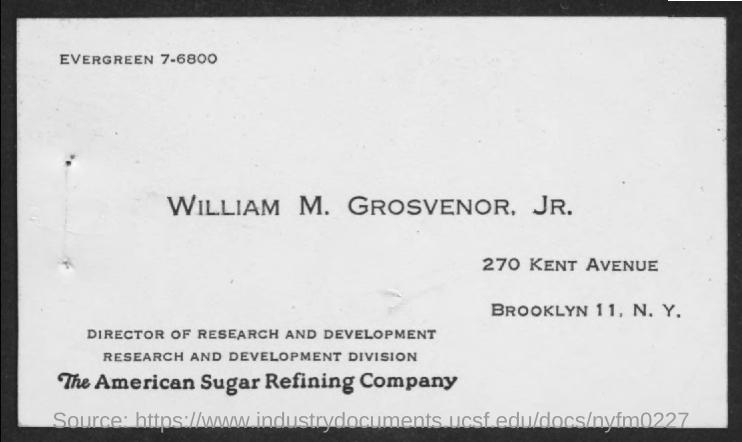What is the position title of William M. Grosvenor, Jr.?
Make the answer very short. Director of Research and Development. 